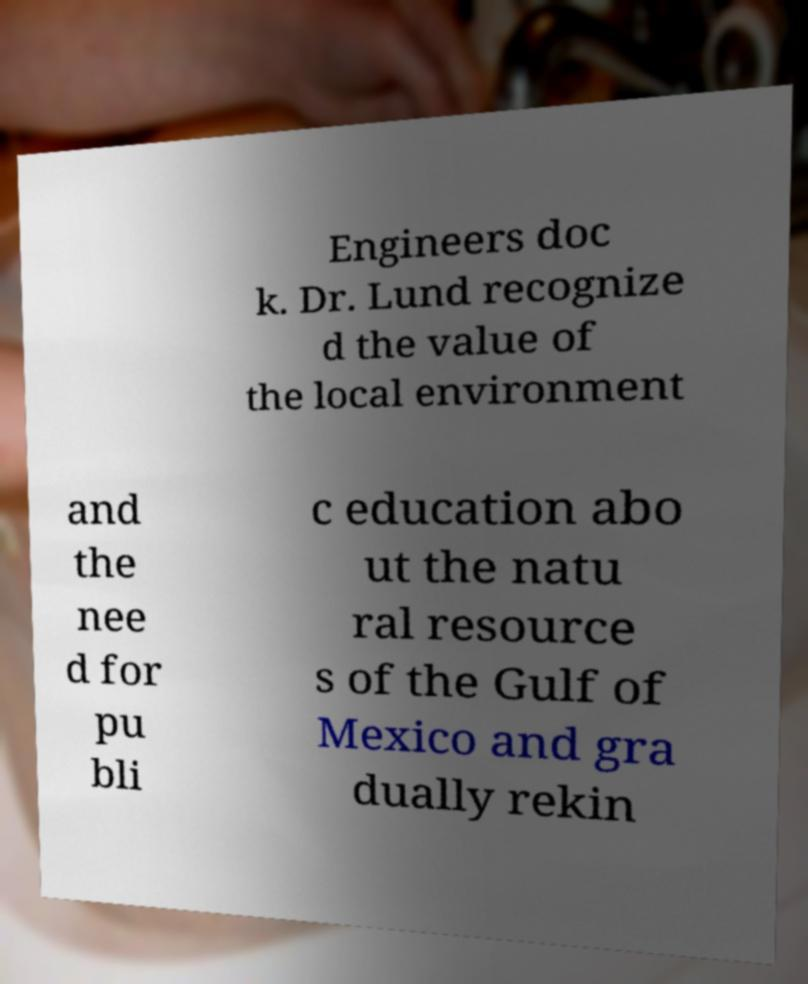Can you read and provide the text displayed in the image?This photo seems to have some interesting text. Can you extract and type it out for me? Engineers doc k. Dr. Lund recognize d the value of the local environment and the nee d for pu bli c education abo ut the natu ral resource s of the Gulf of Mexico and gra dually rekin 